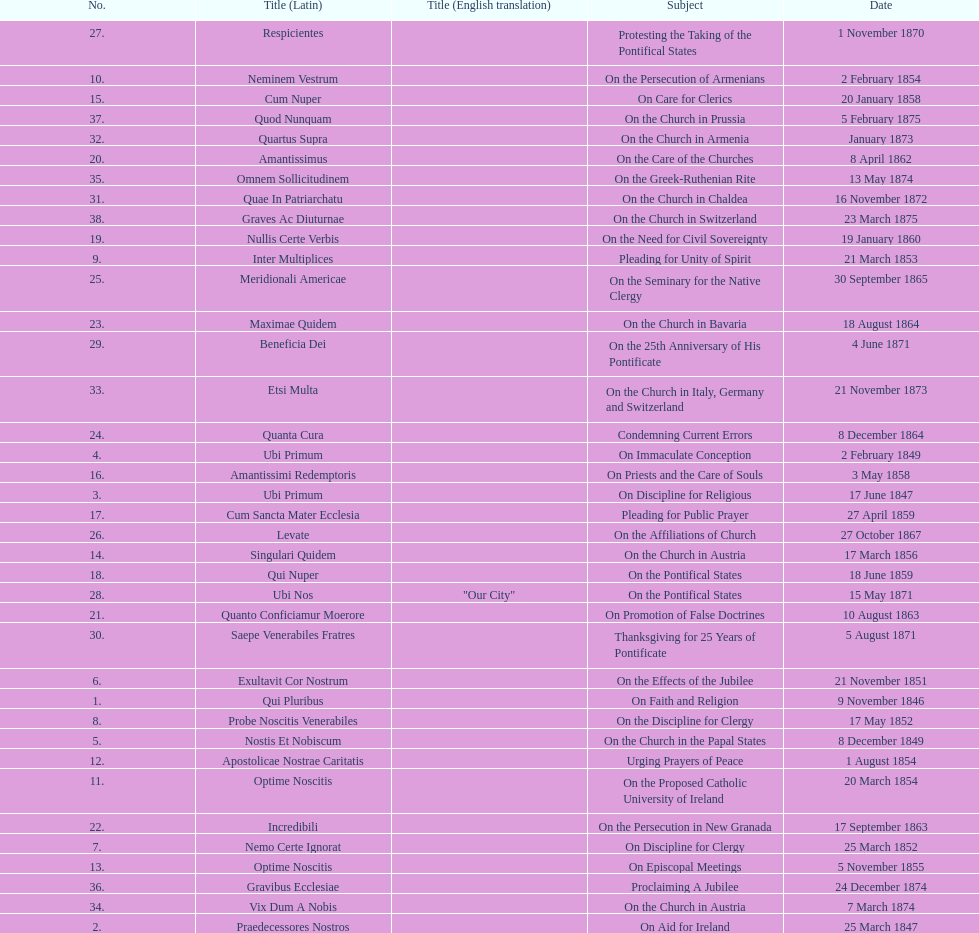During the initial decade of pope pius ix's rule, how many encyclicals did he release? 14. 